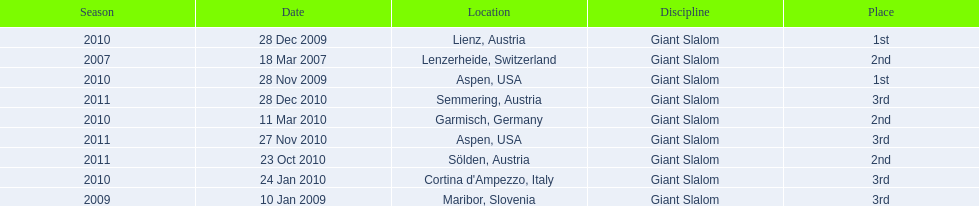What is the total number of her 2nd place finishes on the list? 3. 